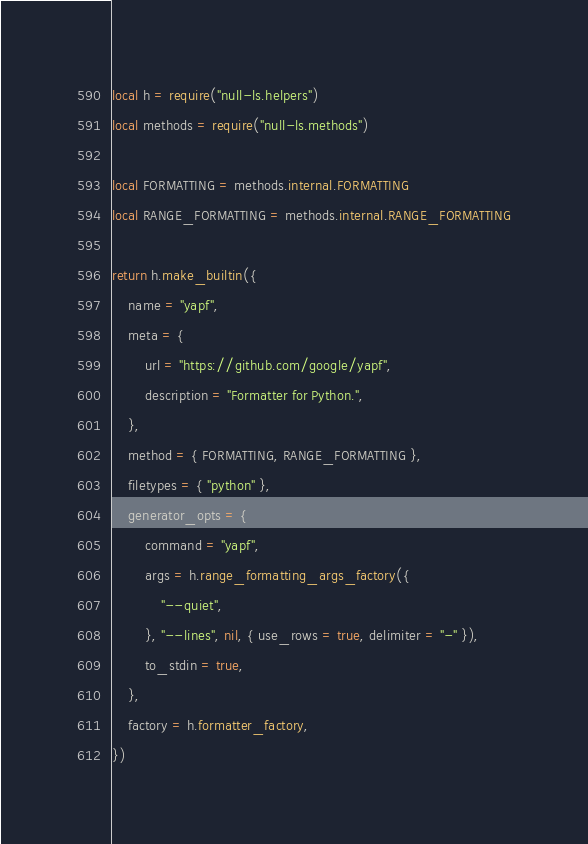<code> <loc_0><loc_0><loc_500><loc_500><_Lua_>local h = require("null-ls.helpers")
local methods = require("null-ls.methods")

local FORMATTING = methods.internal.FORMATTING
local RANGE_FORMATTING = methods.internal.RANGE_FORMATTING

return h.make_builtin({
    name = "yapf",
    meta = {
        url = "https://github.com/google/yapf",
        description = "Formatter for Python.",
    },
    method = { FORMATTING, RANGE_FORMATTING },
    filetypes = { "python" },
    generator_opts = {
        command = "yapf",
        args = h.range_formatting_args_factory({
            "--quiet",
        }, "--lines", nil, { use_rows = true, delimiter = "-" }),
        to_stdin = true,
    },
    factory = h.formatter_factory,
})
</code> 